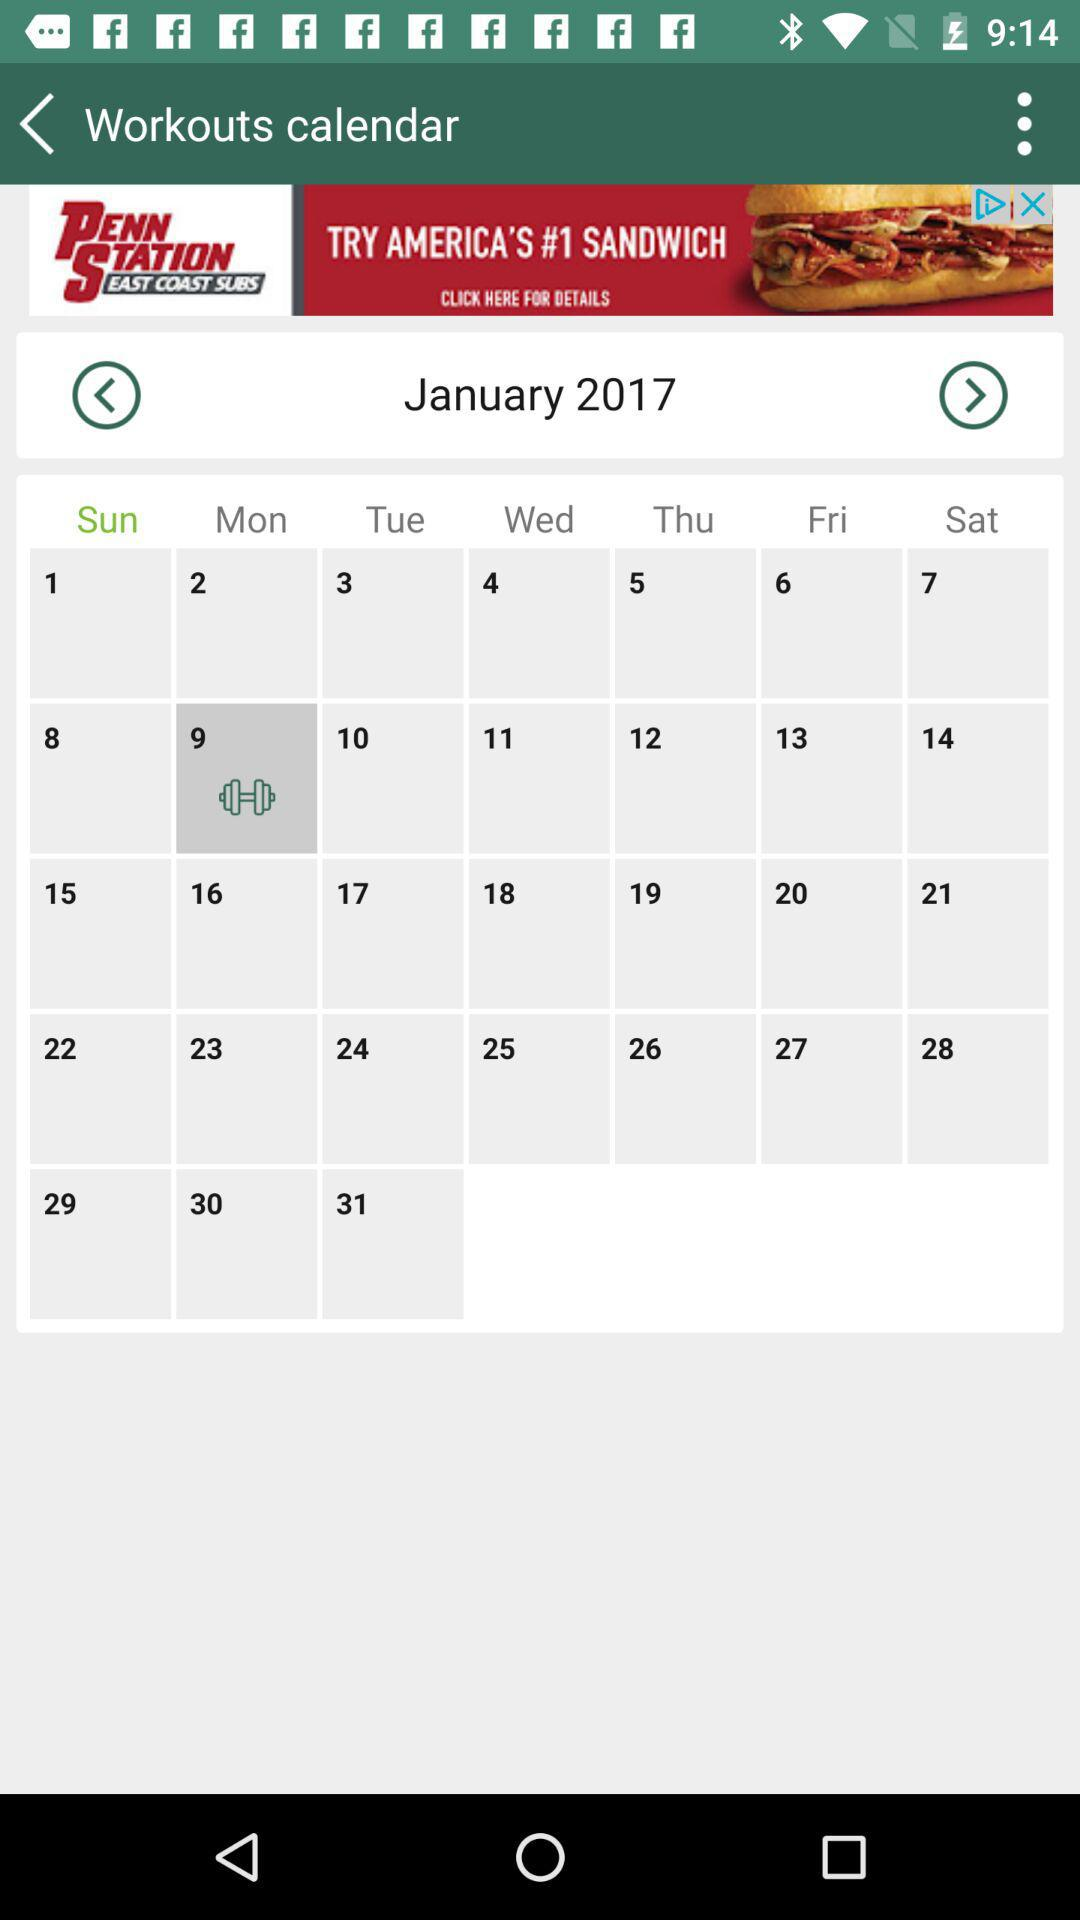What day falls on the 10th of January 2017? The day is "Tuesday". 